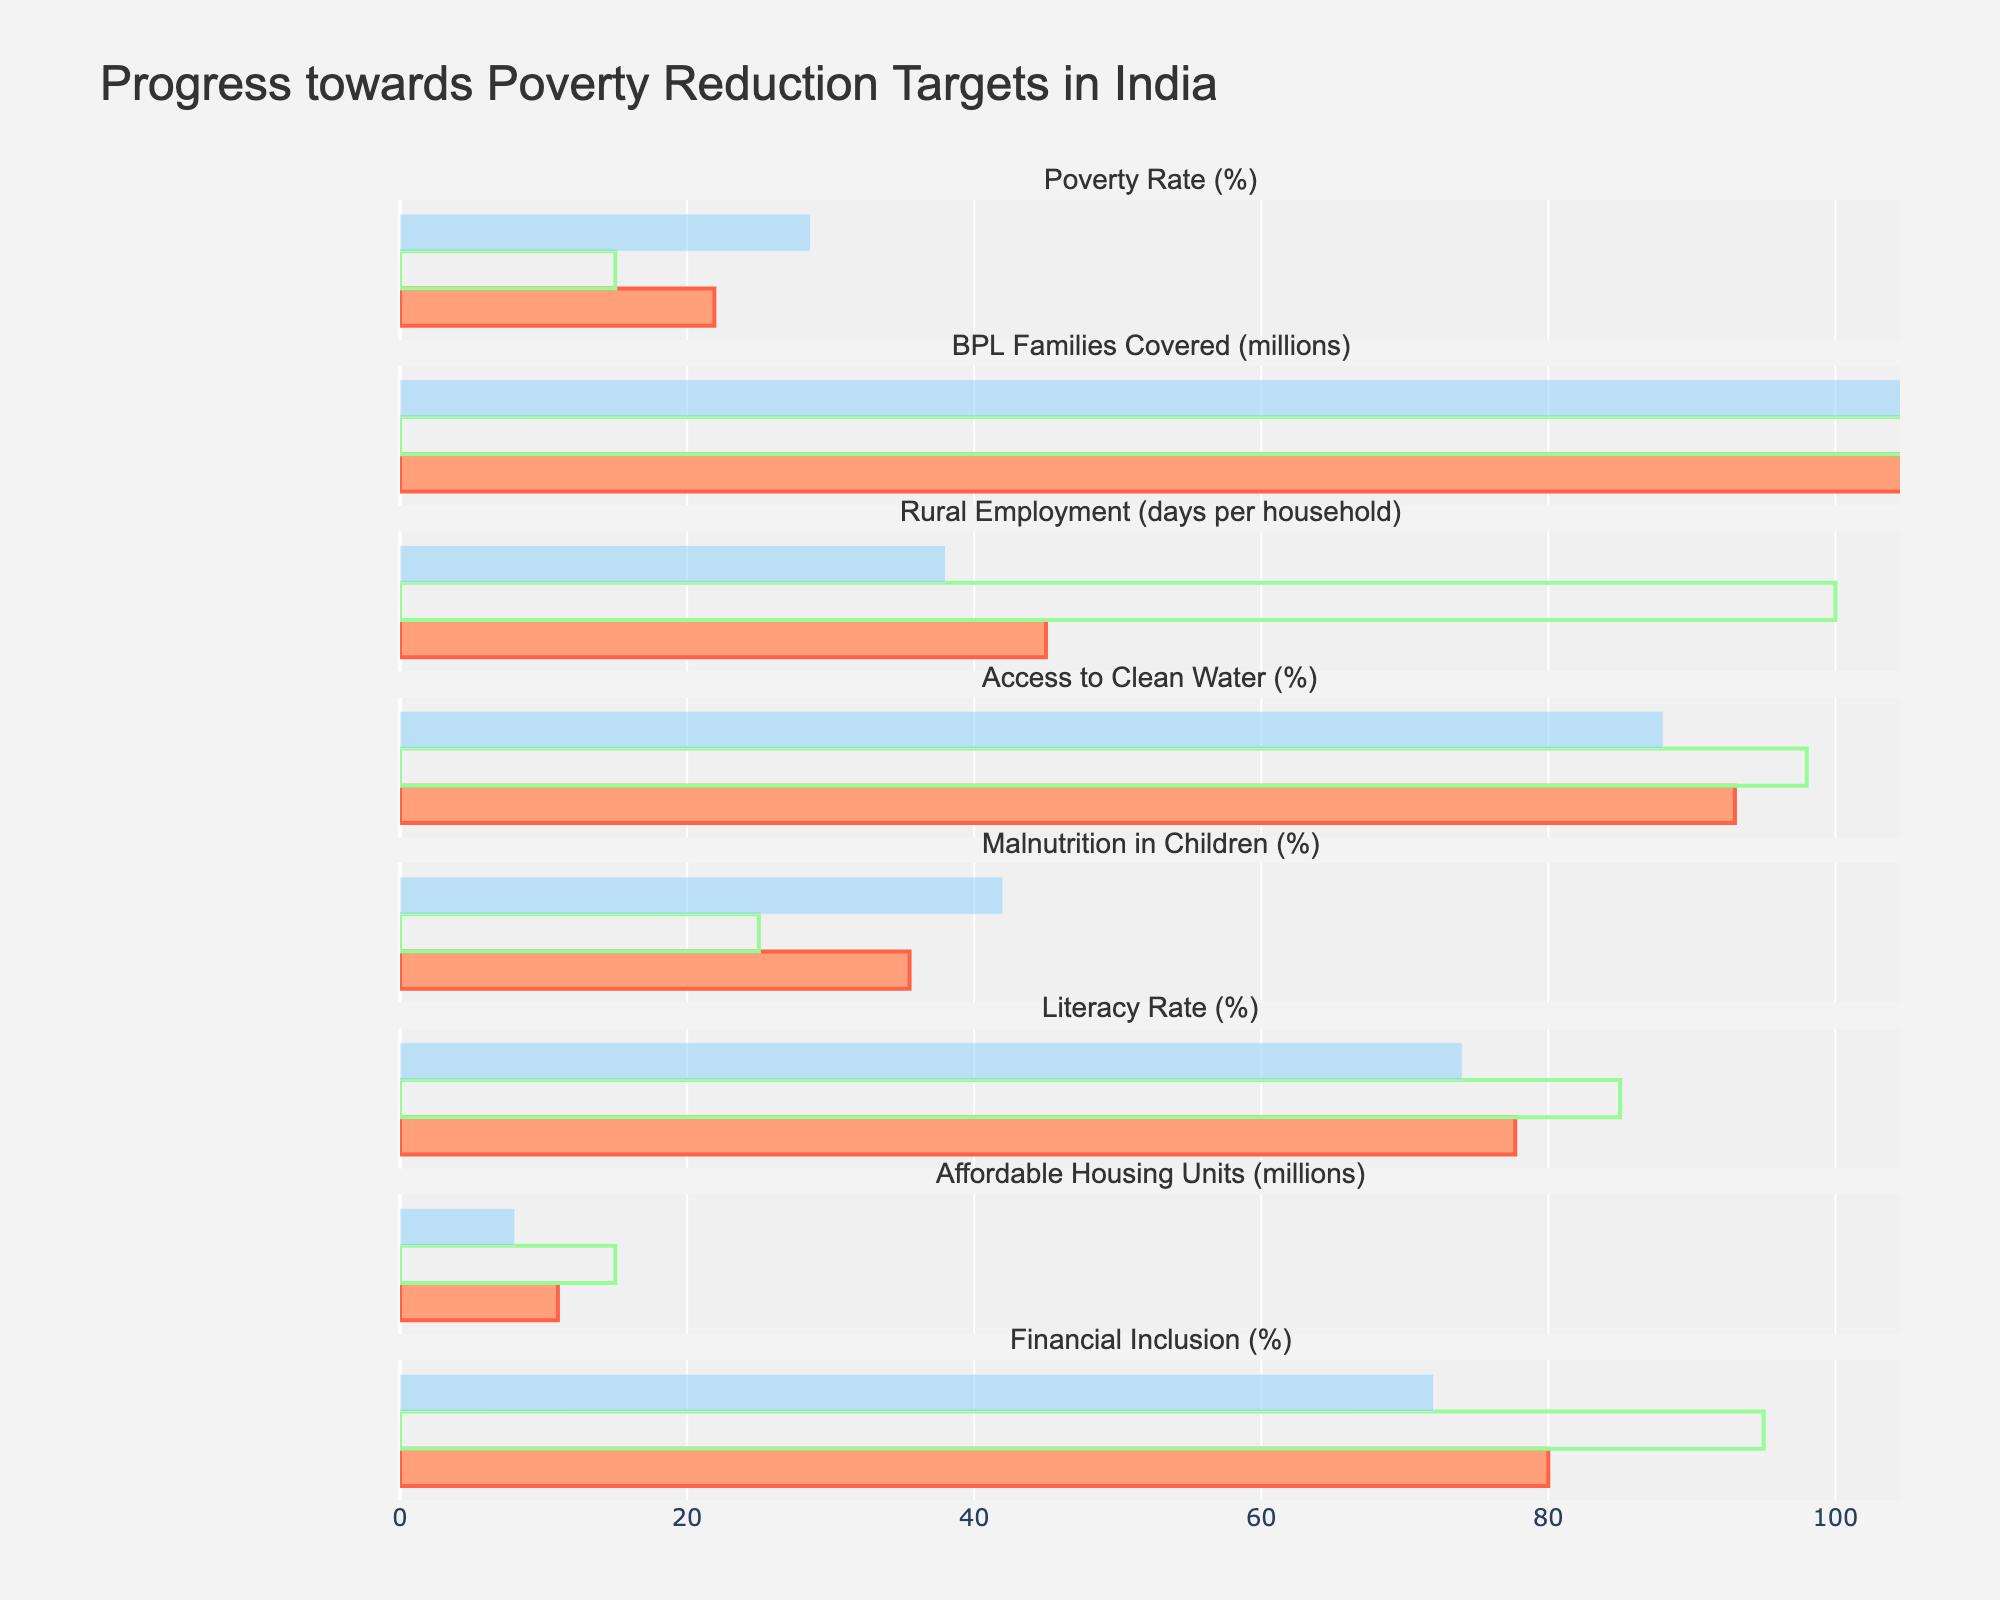What is the title of the figure? The title is usually located at the top of the figure. The given figure's title is "Progress towards Poverty Reduction Targets in India".
Answer: Progress towards Poverty Reduction Targets in India How many categories are displayed in the figure? By examining the figure, we can count the number of unique categories listed on the y-axis. There are 8 categories.
Answer: 8 Which category has the highest actual value, and what is that value? Look at the bars representing the "Actual" values for each category. The category "Access to Clean Water (%)" has the highest actual value, which is 93%.
Answer: Access to Clean Water (%), 93% What is the difference between the actual value and the target value for Poverty Rate? Look at the bars representing the actual and target values for "Poverty Rate (%)". The actual value is 21.9%, and the target value is 15%. The difference is 21.9 - 15 = 6.9%.
Answer: 6.9% Which categories have an actual value greater than the benchmark value? Compare the actual and benchmark bars for each category. The categories "Poverty Rate (%)" (21.9% > 18%), "Rural Employment" (45 > 38), "Access to Clean Water (%)" (93% > 88%), and "Affordable Housing Units (millions)" (11 > 8) meet this criterion.
Answer: Poverty Rate (%), Rural Employment, Access to Clean Water (%), Affordable Housing Units (millions) What is the average target value across all categories? Sum the target values and divide by the number of categories. The target values are 15, 300, 100, 98, 25, 85, 15, and 95. (15 + 300 + 100 + 98 + 25 + 85 + 15 + 95) / 8 = 91.625.
Answer: 91.625 Which category is closest to achieving its target? Calculate the difference between the actual and target values for each category. The category with the smallest difference is closest. "Access to Clean Water (%)" has an actual value of 93% and a target of 98%, a difference of 5%, which is the smallest.
Answer: Access to Clean Water (%) Are there any categories where the actual value is less than the benchmark value? Compare the actual and benchmark bars for each category. The category "Malnutrition in Children (%)" (35.5% < 42%) meets this criterion.
Answer: Malnutrition in Children (%) What is the range of the actual values for all categories? Find the largest and smallest actual values. The largest value is 235 (BPL Families Covered (millions)), and the smallest value is 11 (Affordable Housing Units (millions)). The range is 235 - 11 = 224.
Answer: 224 